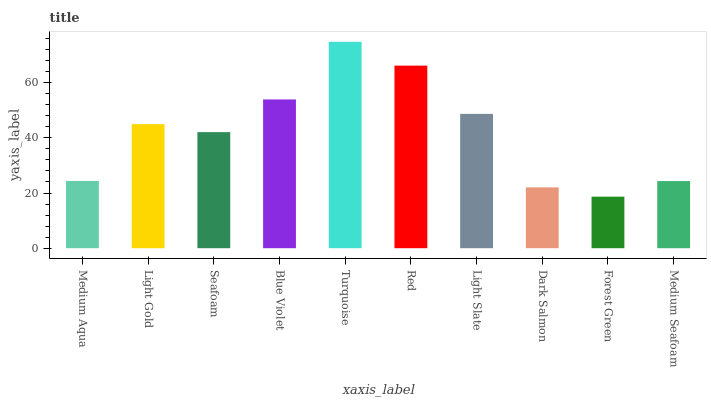Is Light Gold the minimum?
Answer yes or no. No. Is Light Gold the maximum?
Answer yes or no. No. Is Light Gold greater than Medium Aqua?
Answer yes or no. Yes. Is Medium Aqua less than Light Gold?
Answer yes or no. Yes. Is Medium Aqua greater than Light Gold?
Answer yes or no. No. Is Light Gold less than Medium Aqua?
Answer yes or no. No. Is Light Gold the high median?
Answer yes or no. Yes. Is Seafoam the low median?
Answer yes or no. Yes. Is Light Slate the high median?
Answer yes or no. No. Is Forest Green the low median?
Answer yes or no. No. 